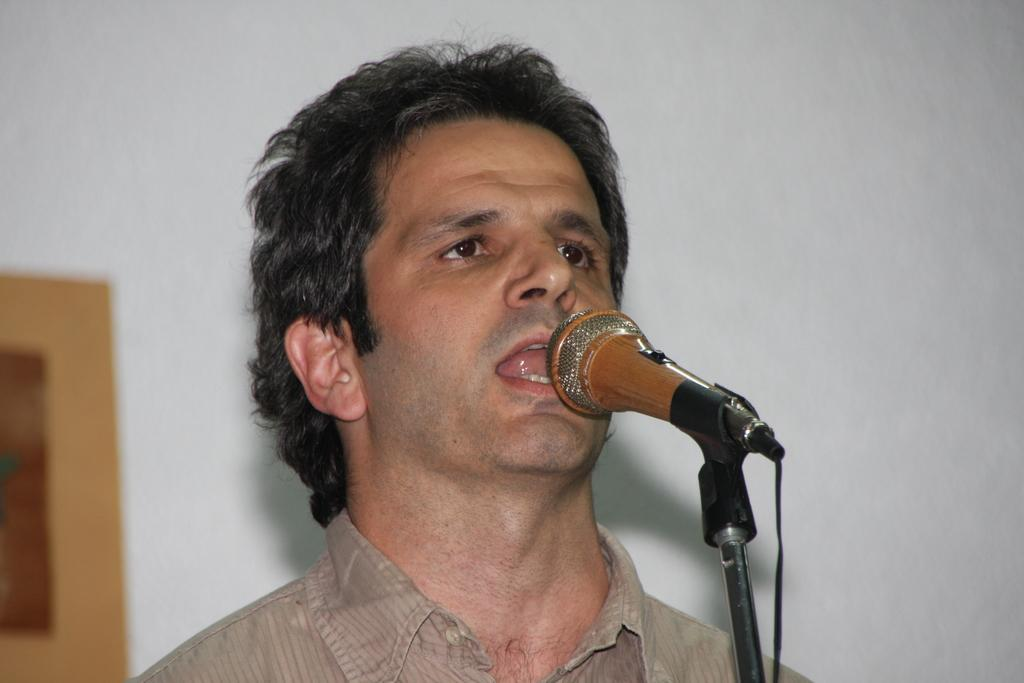Where was the image taken? The image is taken indoors. What can be seen in the background of the image? There is a wall with a picture frame in the background. Who is the main subject in the image? A man is present in the middle of the image. What is the man doing in the image? The man is singing on a microphone. What type of mitten is the man wearing while singing on the microphone? The man is not wearing a mitten in the image; he is singing on a microphone without any gloves or mittens. 